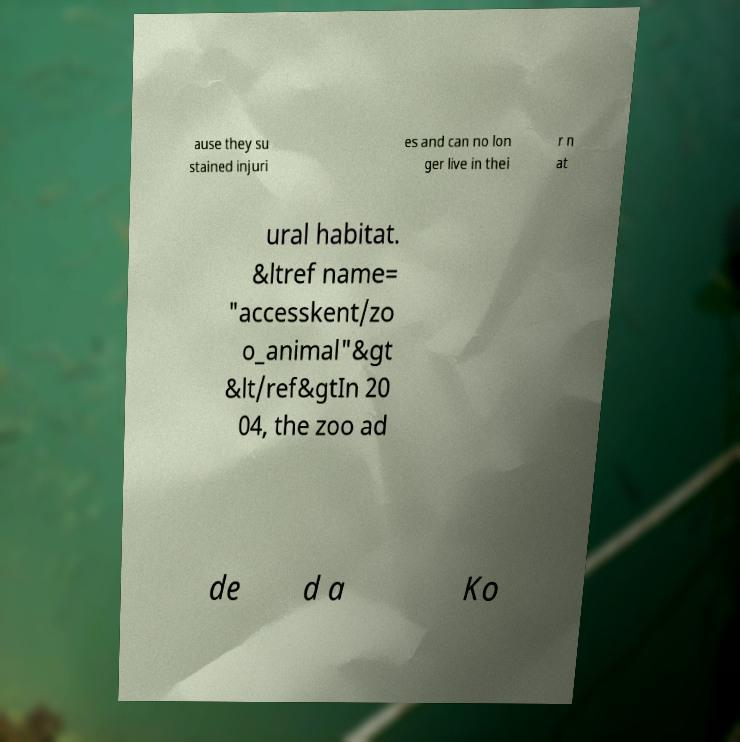Could you assist in decoding the text presented in this image and type it out clearly? ause they su stained injuri es and can no lon ger live in thei r n at ural habitat. &ltref name= "accesskent/zo o_animal"&gt &lt/ref&gtIn 20 04, the zoo ad de d a Ko 